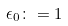<formula> <loc_0><loc_0><loc_500><loc_500>\epsilon _ { 0 } \colon = 1</formula> 